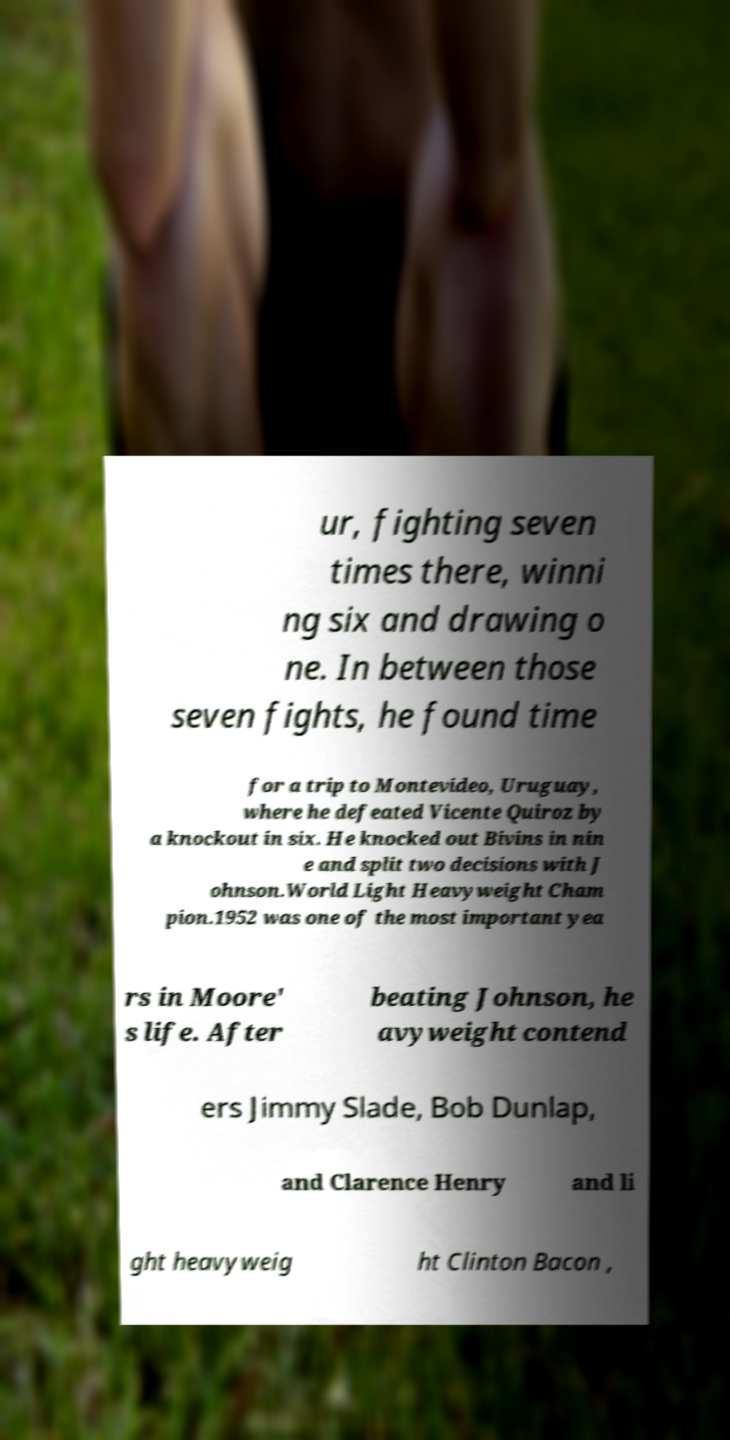There's text embedded in this image that I need extracted. Can you transcribe it verbatim? ur, fighting seven times there, winni ng six and drawing o ne. In between those seven fights, he found time for a trip to Montevideo, Uruguay, where he defeated Vicente Quiroz by a knockout in six. He knocked out Bivins in nin e and split two decisions with J ohnson.World Light Heavyweight Cham pion.1952 was one of the most important yea rs in Moore' s life. After beating Johnson, he avyweight contend ers Jimmy Slade, Bob Dunlap, and Clarence Henry and li ght heavyweig ht Clinton Bacon , 